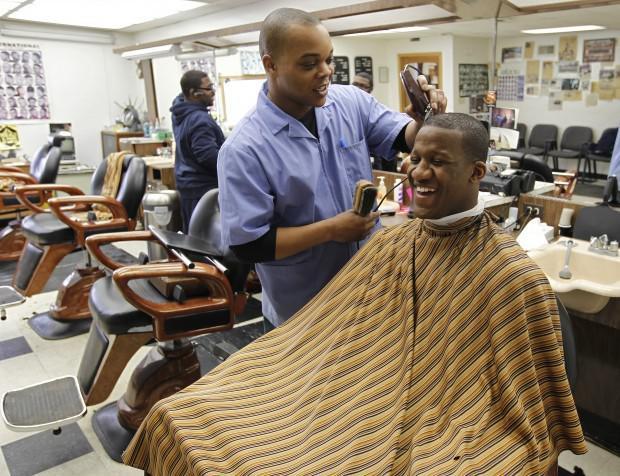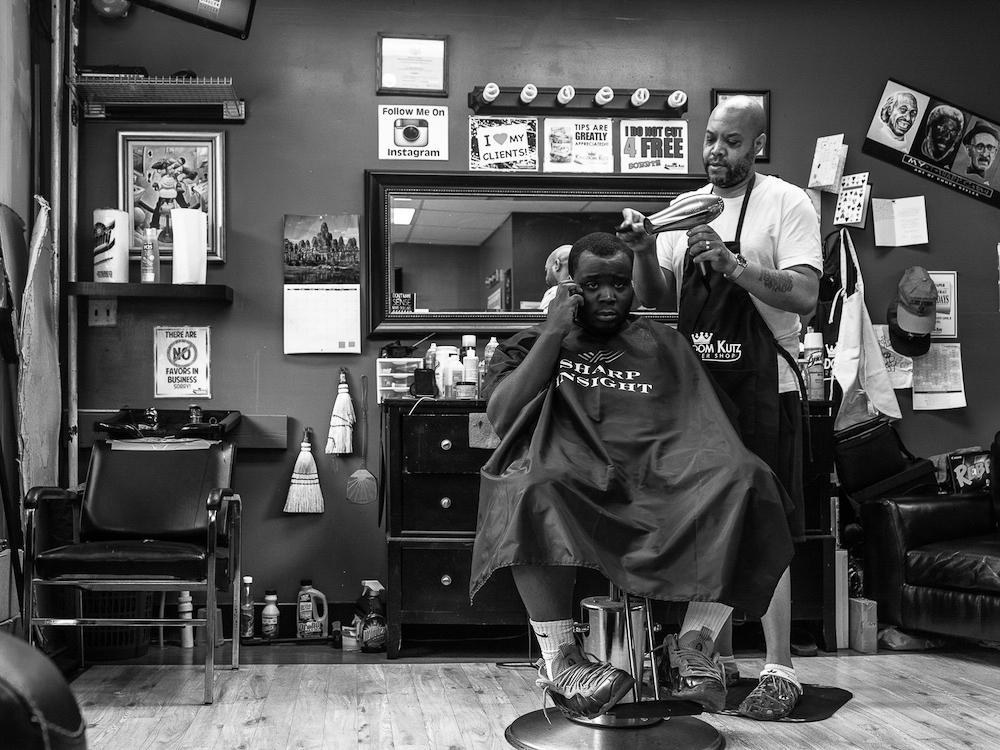The first image is the image on the left, the second image is the image on the right. For the images displayed, is the sentence "In each image, there is more than one person sitting down." factually correct? Answer yes or no. No. The first image is the image on the left, the second image is the image on the right. Examine the images to the left and right. Is the description "the picture i=on the left is in color" accurate? Answer yes or no. Yes. 